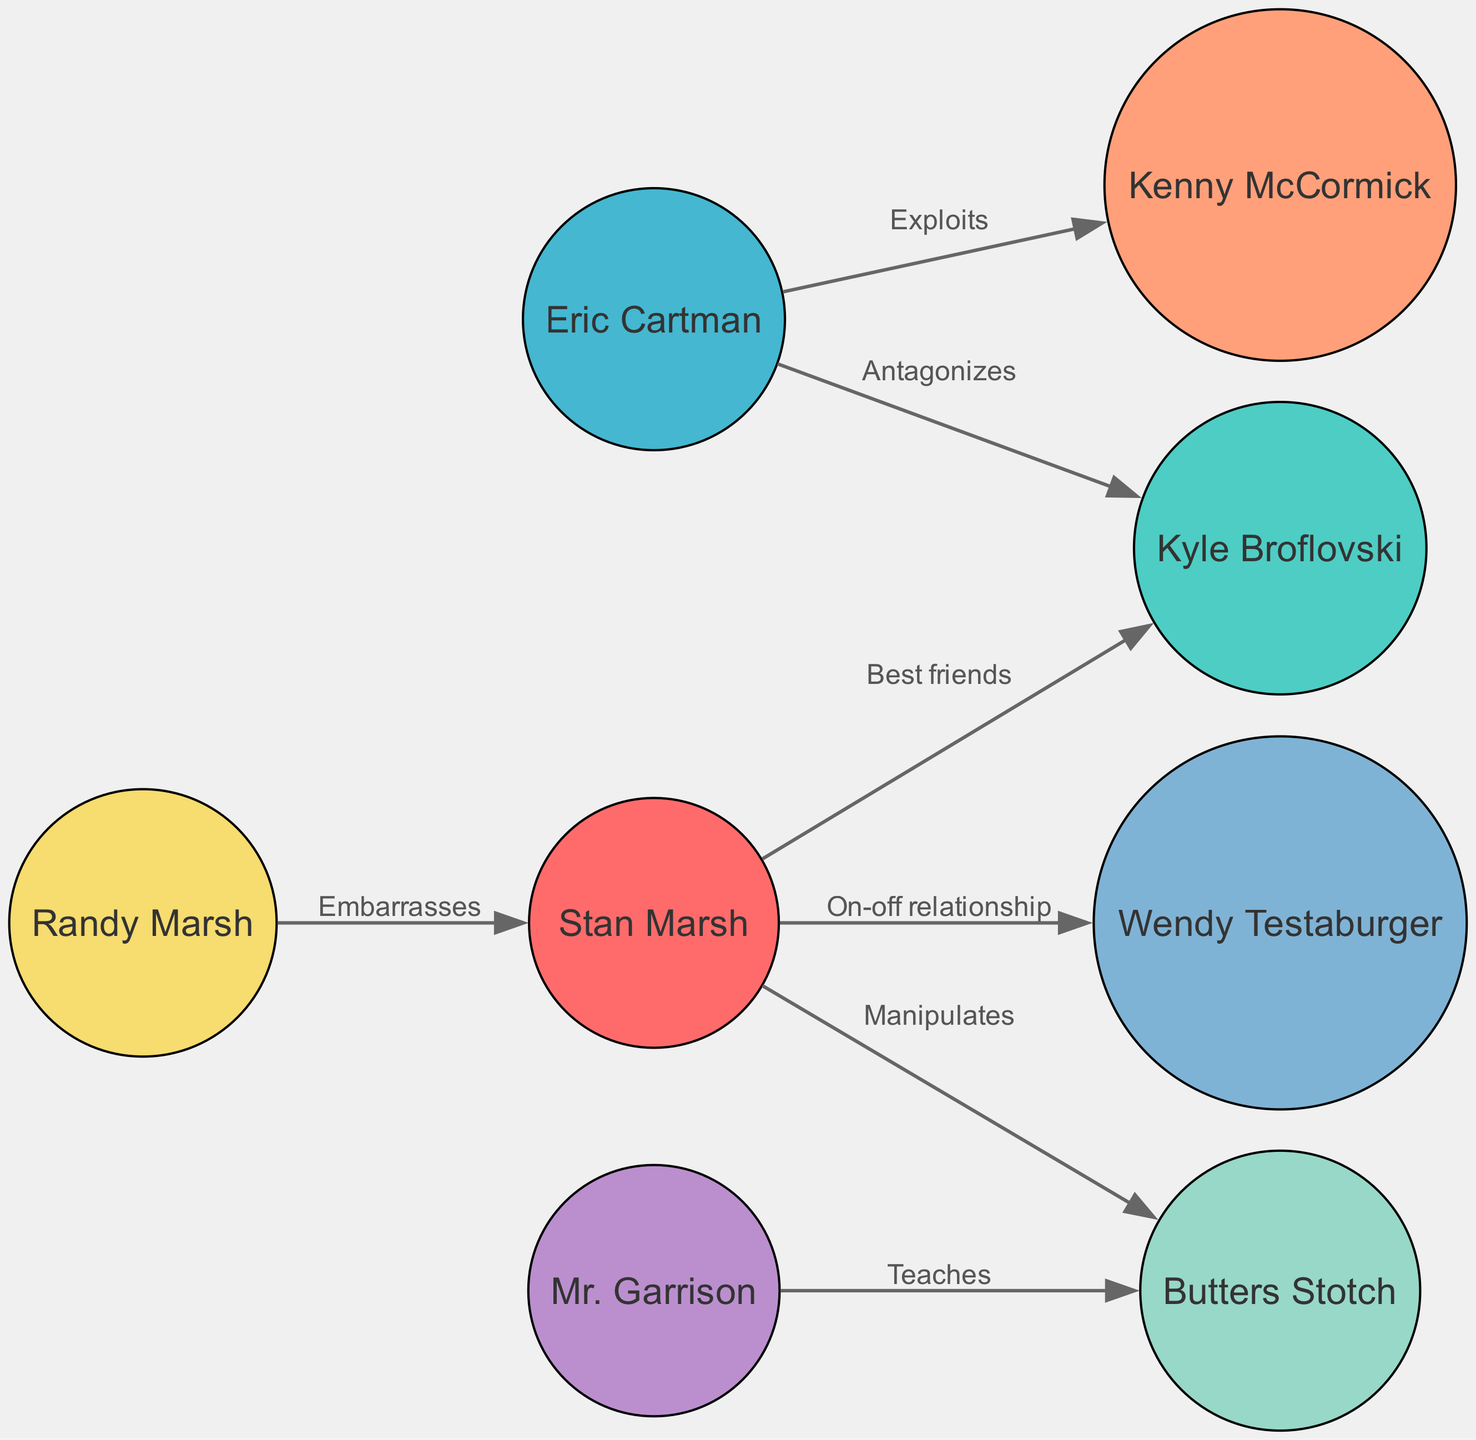What is the total number of nodes in the diagram? The diagram contains a list of character nodes, which are: Stan Marsh, Kyle Broflovski, Eric Cartman, Kenny McCormick, Butters Stotch, Randy Marsh, Mr. Garrison, and Wendy Testaburger. Counting these characters gives us a total of 8 nodes.
Answer: 8 What type of relationship exists between Stan Marsh and Kyle Broflovski? The edge connecting Stan Marsh and Kyle Broflovski is labeled "Best friends." This label describes their relationship directly, indicating that they share a close friendship.
Answer: Best friends Who does Eric Cartman antagonize? The directed edge from Eric Cartman to Kyle Broflovski is labeled "Antagonizes." This indicates that Eric Cartman has a contentious relationship specifically with Kyle Broflovski.
Answer: Kyle Broflovski How does Stan Marsh interact with Butters Stotch? There are two edges involving Stan Marsh and Butters Stotch: one is labeled "Manipulates," which indicates that Stan has some influence over Butters, while the other is not directly between them, suggesting a one-way interaction. Therefore, the primary interaction is manipulation.
Answer: Manipulates Between which two characters is there an "On-off relationship"? The edge that describes an "On-off relationship" is between Stan Marsh and Wendy Testaburger. The label clearly identifies the specific nature of their interaction, which suggests fluctuations in their relationship status.
Answer: Stan Marsh and Wendy Testaburger How many edges are present in the diagram? The diagram contains several directed edges that illustrate relationships between characters. Counting them includes one from Stan Marsh to Kyle Broflovski, one from Eric Cartman to Kyle Broflovski, etc. A total of 7 edges can be counted from the provided relationships.
Answer: 7 What role does Mr. Garrison have with Butters Stotch? The edge from Mr. Garrison to Butters Stotch is labeled "Teaches," clearly indicating that Mr. Garrison has a teaching role toward Butters. This interaction suggests an educational relationship.
Answer: Teaches Which character is embarrassed by Randy Marsh? The edge from Randy Marsh to Stan Marsh is labeled "Embarrasses." This relationship clearly outlines the nature of interaction as one where Randy causes embarrassment to Stan.
Answer: Stan Marsh How many characters does Eric Cartman exploit? Eric Cartman is shown to have an exploitative relationship with one character, Kenny McCormick, as evidenced by the edge labeled "Exploits." Thus, he exploits only one character in the diagram.
Answer: Kenny McCormick 